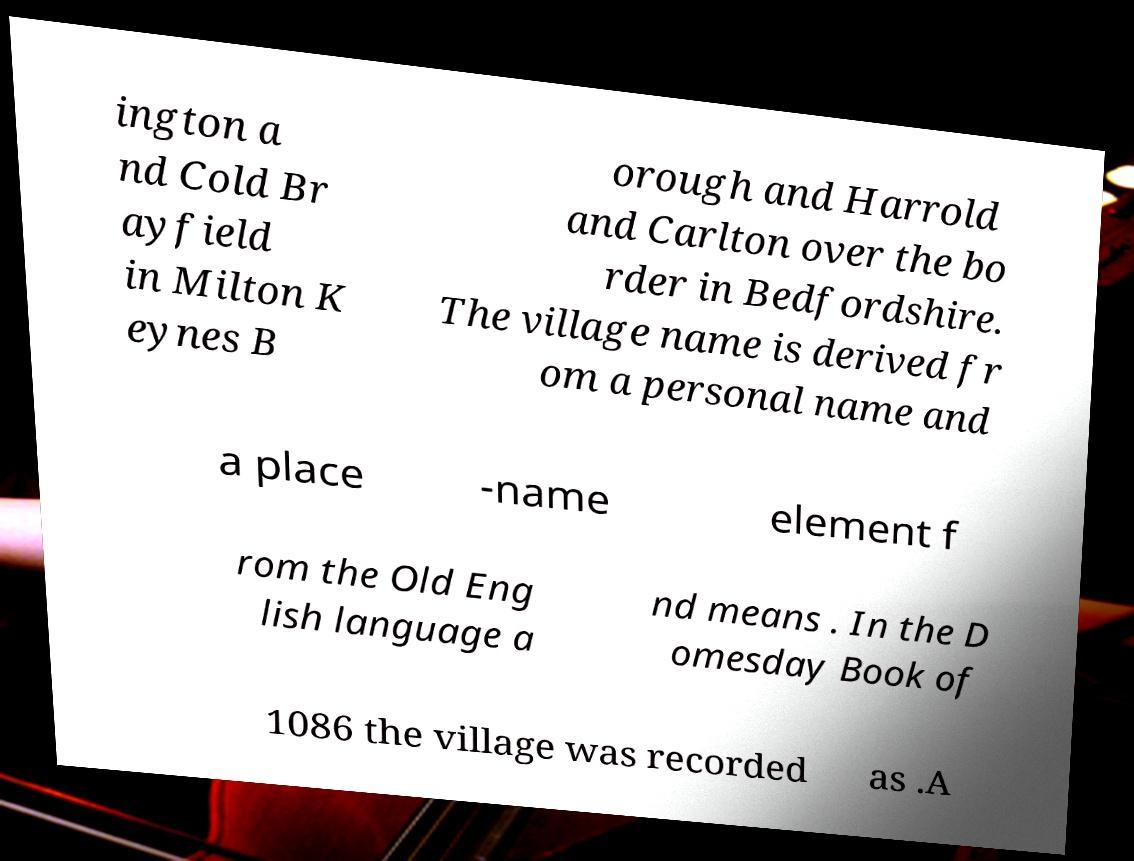Could you extract and type out the text from this image? ington a nd Cold Br ayfield in Milton K eynes B orough and Harrold and Carlton over the bo rder in Bedfordshire. The village name is derived fr om a personal name and a place -name element f rom the Old Eng lish language a nd means . In the D omesday Book of 1086 the village was recorded as .A 